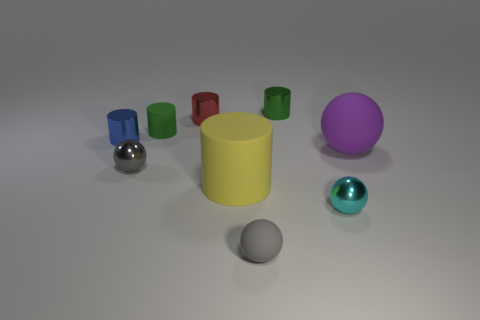How many things are either purple matte cubes or red metal cylinders?
Ensure brevity in your answer.  1. Do the large object on the right side of the yellow cylinder and the small rubber thing that is to the left of the small red metal object have the same shape?
Give a very brief answer. No. How many metallic things are in front of the small blue metal cylinder and behind the cyan ball?
Provide a succinct answer. 1. How many other objects are there of the same size as the yellow object?
Offer a very short reply. 1. There is a object that is behind the small blue metal thing and in front of the red cylinder; what material is it?
Provide a succinct answer. Rubber. Is the color of the large ball the same as the tiny rubber thing that is behind the blue metallic cylinder?
Your answer should be very brief. No. What size is the blue object that is the same shape as the yellow matte object?
Make the answer very short. Small. The shiny object that is left of the green shiny cylinder and behind the blue thing has what shape?
Your response must be concise. Cylinder. Is the size of the red object the same as the matte cylinder that is in front of the blue metal cylinder?
Your response must be concise. No. There is a big matte object that is the same shape as the small gray shiny thing; what color is it?
Provide a short and direct response. Purple. 